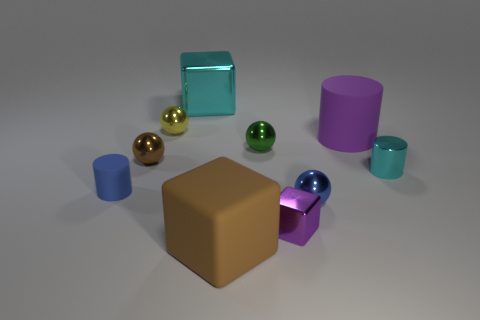Is there a consistent light source observable in the image, and if so, where does it appear to be coming from? Yes, there is a consistent light source in the image. Observing the shadows and highlights, it appears to originate from the upper left corner, somewhat out of frame.  Among the spheres, which one would you say is located closest to the front? The dark green sphere is the one situated closest to the front of the image, based on its size and position relative to the other spheres. 